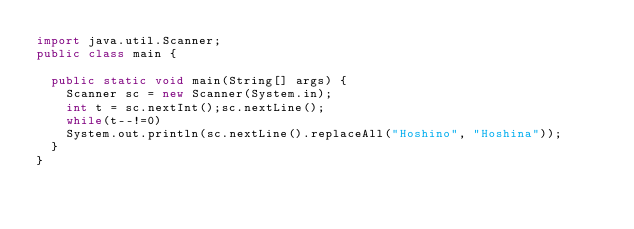Convert code to text. <code><loc_0><loc_0><loc_500><loc_500><_Java_>import java.util.Scanner;
public class main {

	public static void main(String[] args) {
		Scanner sc = new Scanner(System.in);
		int t = sc.nextInt();sc.nextLine();
		while(t--!=0)
		System.out.println(sc.nextLine().replaceAll("Hoshino", "Hoshina"));
	}
}</code> 